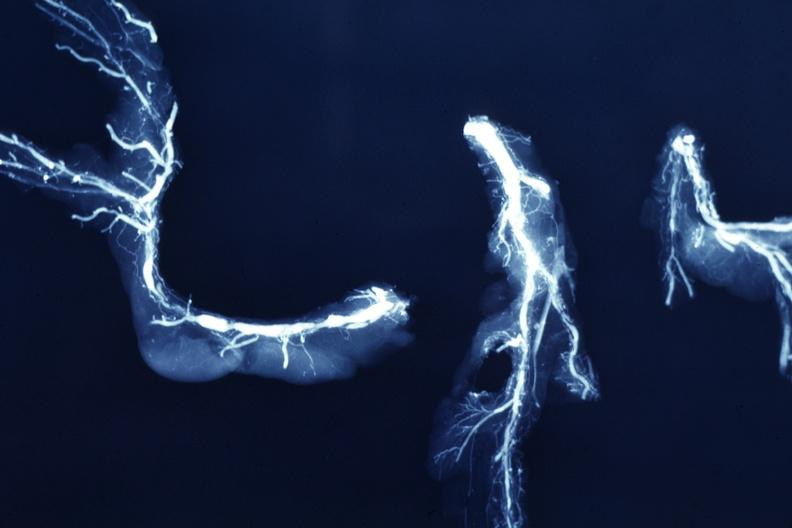what postmortdissected arteries extensive lesions?
Answer the question using a single word or phrase. X-ray 